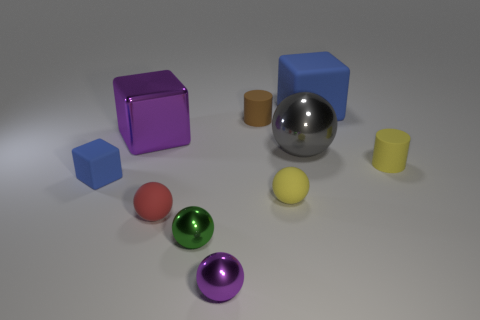Subtract all large gray metal balls. How many balls are left? 4 Subtract all red spheres. How many spheres are left? 4 Subtract all cyan spheres. Subtract all purple cubes. How many spheres are left? 5 Subtract all cubes. How many objects are left? 7 Add 4 red things. How many red things exist? 5 Subtract 1 gray spheres. How many objects are left? 9 Subtract all tiny cyan matte cylinders. Subtract all cylinders. How many objects are left? 8 Add 9 small red rubber objects. How many small red rubber objects are left? 10 